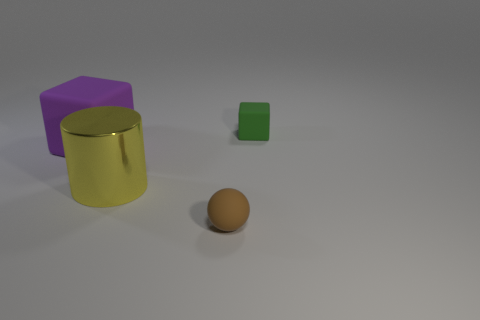Add 3 purple cubes. How many objects exist? 7 Subtract all purple blocks. How many blocks are left? 1 Subtract all cylinders. How many objects are left? 3 Subtract 1 blocks. How many blocks are left? 1 Subtract all blue blocks. Subtract all red spheres. How many blocks are left? 2 Subtract all small red matte things. Subtract all large purple blocks. How many objects are left? 3 Add 2 small matte spheres. How many small matte spheres are left? 3 Add 3 big blue cylinders. How many big blue cylinders exist? 3 Subtract 0 cyan spheres. How many objects are left? 4 